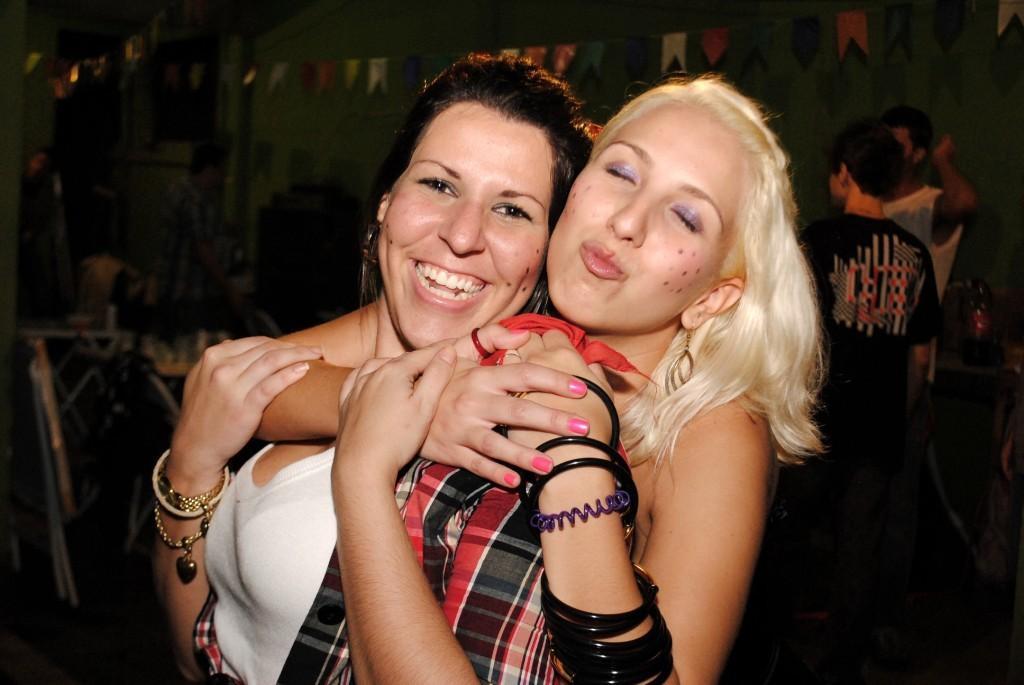In one or two sentences, can you explain what this image depicts? In the image we can see there are two women wearing clothes, bangle, bracelet and earrings, this woman is smiling and other one is pouting. Behind them there are other people, these are the decorating papers and there are the other objects. 